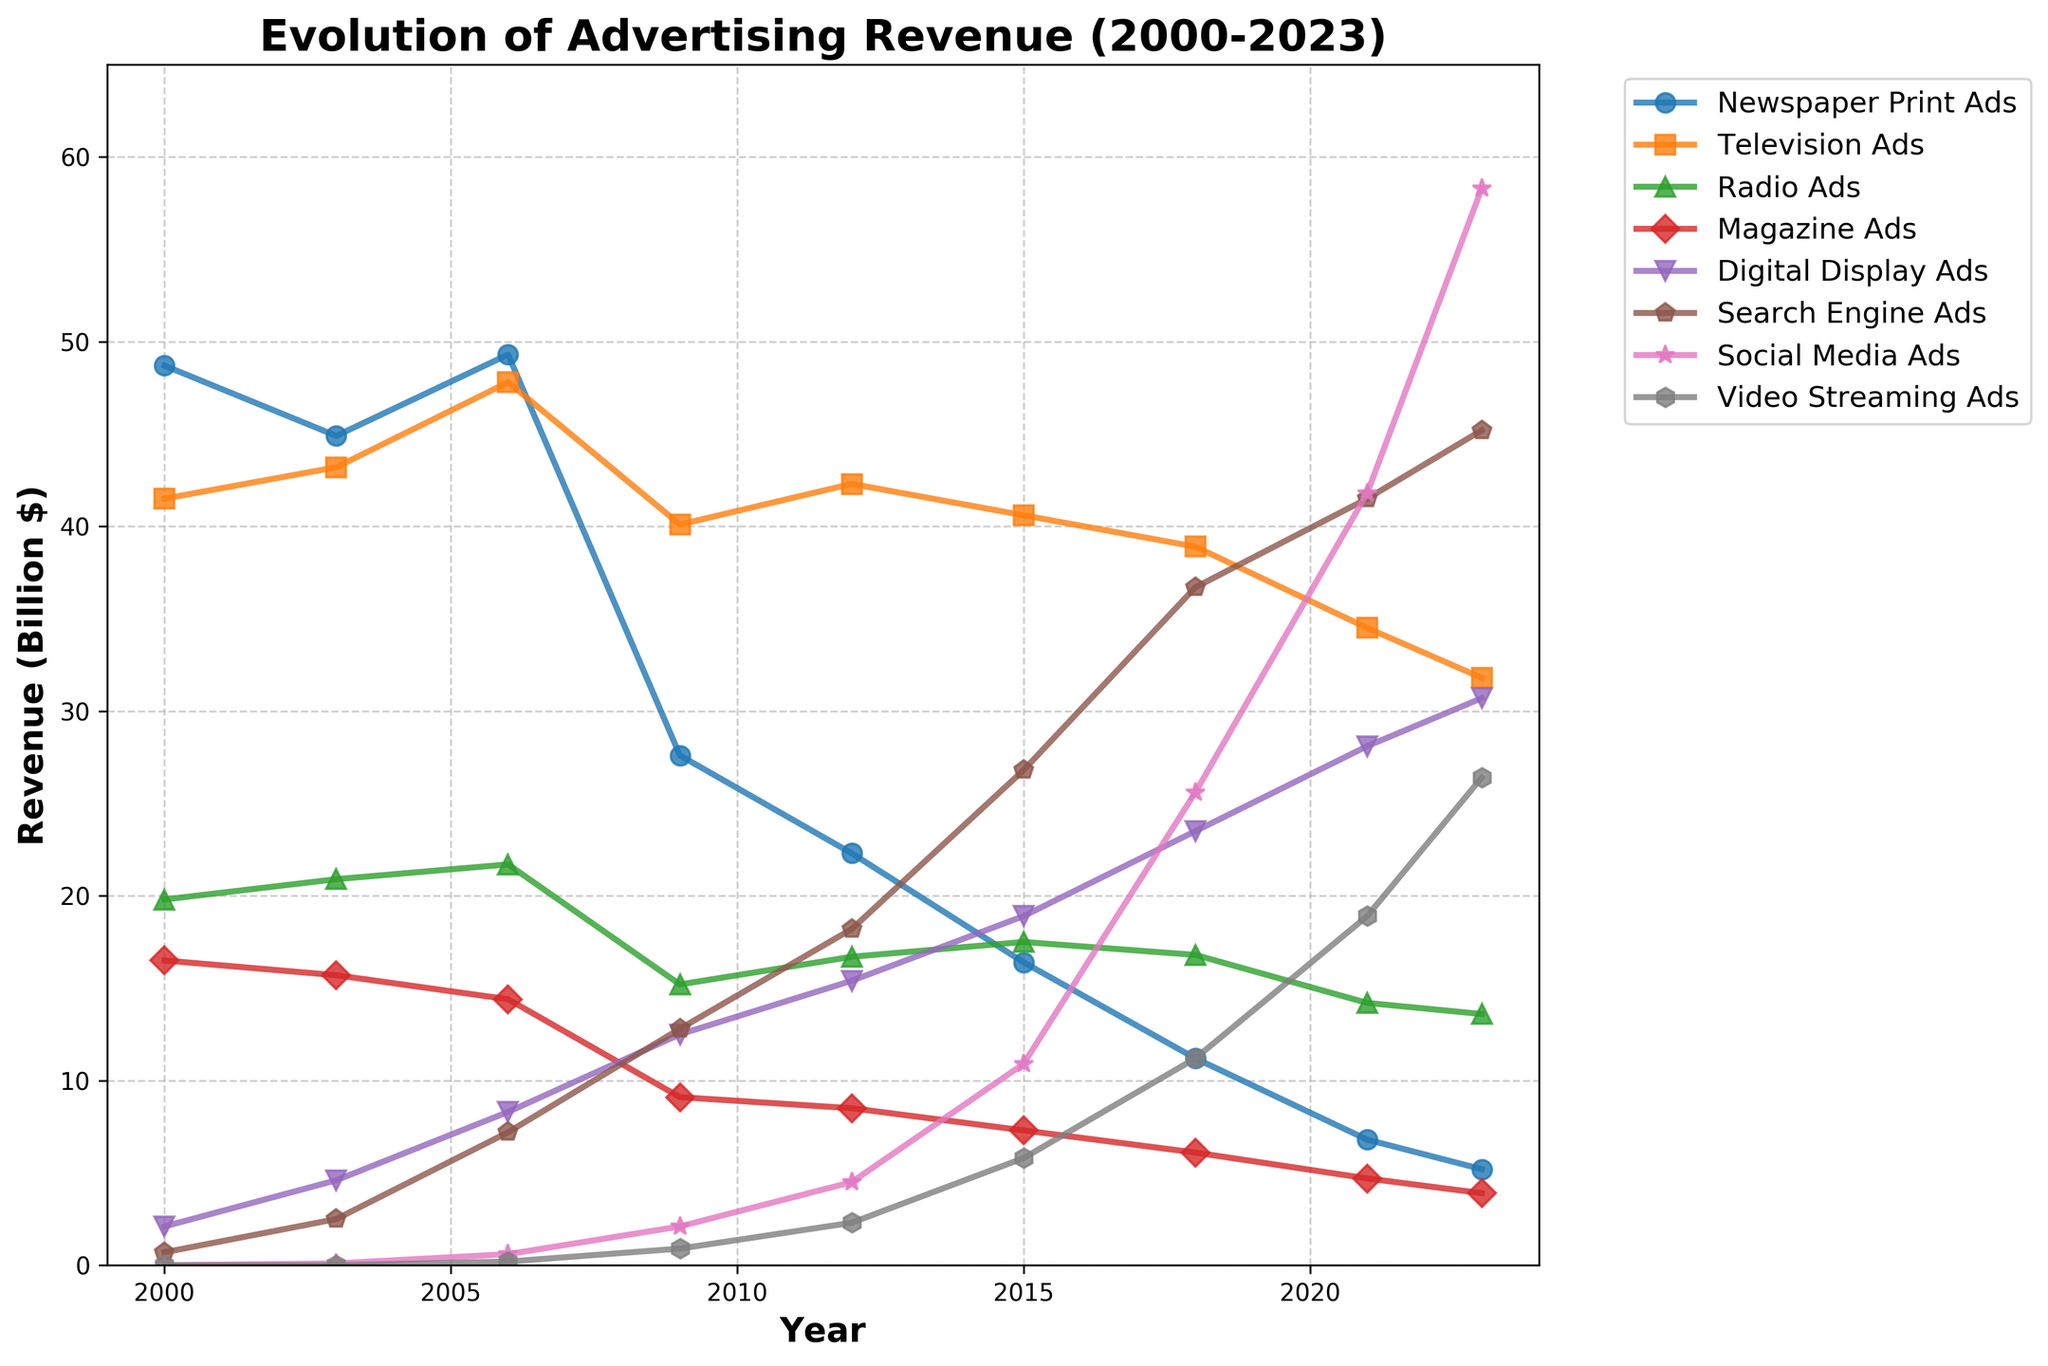What was the revenue difference between Digital Display Ads and Newspaper Print Ads in 2023? First, find the revenue for Digital Display Ads in 2023, which is 30.7 billion dollars. Next, find the revenue for Newspaper Print Ads in 2023, which is 5.2 billion dollars. The difference is 30.7 - 5.2.
Answer: 25.5 billion dollars Which type of ad had the highest revenue in 2021? Look at the revenue values for all types of ads in 2021. Social Media Ads had the highest revenue with 41.8 billion dollars.
Answer: Social Media Ads How has the revenue for Television Ads changed from 2000 to 2023? Find the revenue for Television Ads in 2000, which is 41.5 billion dollars, and in 2023, which is 31.8 billion dollars. Then calculate the change: 31.8 - 41.5.
Answer: Decreased by 9.7 billion dollars What is the trend for revenue in Magazine Ads from 2000 to 2023? Observe the points for Magazine Ads from 2000 to 2023 on the graph. The revenue starts at 16.5 billion dollars in 2000 and steadily declines to 3.9 billion dollars in 2023.
Answer: Decreasing In which year did Digital Display Ads surpass Television Ads in revenue? Look for the year where the line representing Digital Display Ads crosses above the line for Television Ads. This happens around 2021.
Answer: 2021 What was the revenue for Radio Ads and Search Engine Ads combined in 2009? Find the revenue for Radio Ads and Search Engine Ads in 2009. Radio Ads had 15.2 billion dollars and Search Engine Ads had 12.8 billion dollars. Add these values: 15.2 + 12.8.
Answer: 28 billion dollars Which type of ad experienced the most significant increase in revenue from 2000 to 2023? Compare the revenues in 2000 and 2023 for all types of ads and calculate the differences. Social Media Ads show the largest increase: from 0 in 2000 to 58.3 billion dollars in 2023.
Answer: Social Media Ads How does the revenue for Video Streaming Ads in 2023 compare to the revenue for Magazine Ads in 2018? Find the revenue for Video Streaming Ads in 2023, which is 26.4 billion dollars, and the revenue for Magazine Ads in 2018, which is 6.1 billion dollars. Compare these values.
Answer: Video Streaming Ads are higher by 20.3 billion dollars What is the average revenue for Digital Display Ads from 2000 to 2023? Sum the revenue values for Digital Display Ads for each year and divide by the number of years. The values are 2.1, 4.6, 8.3, 12.5, 15.4, 18.9, 23.5, 28.1, and 30.7. The total sum is 144.1 billion dollars over 9 years: 144.1 / 9.
Answer: 16 billion dollars Which type of ad had the smallest revenue in 2003? Compare the revenue values for all types of ads in 2003. Social Media Ads had the smallest revenue with 0.1 billion dollars.
Answer: Social Media Ads 